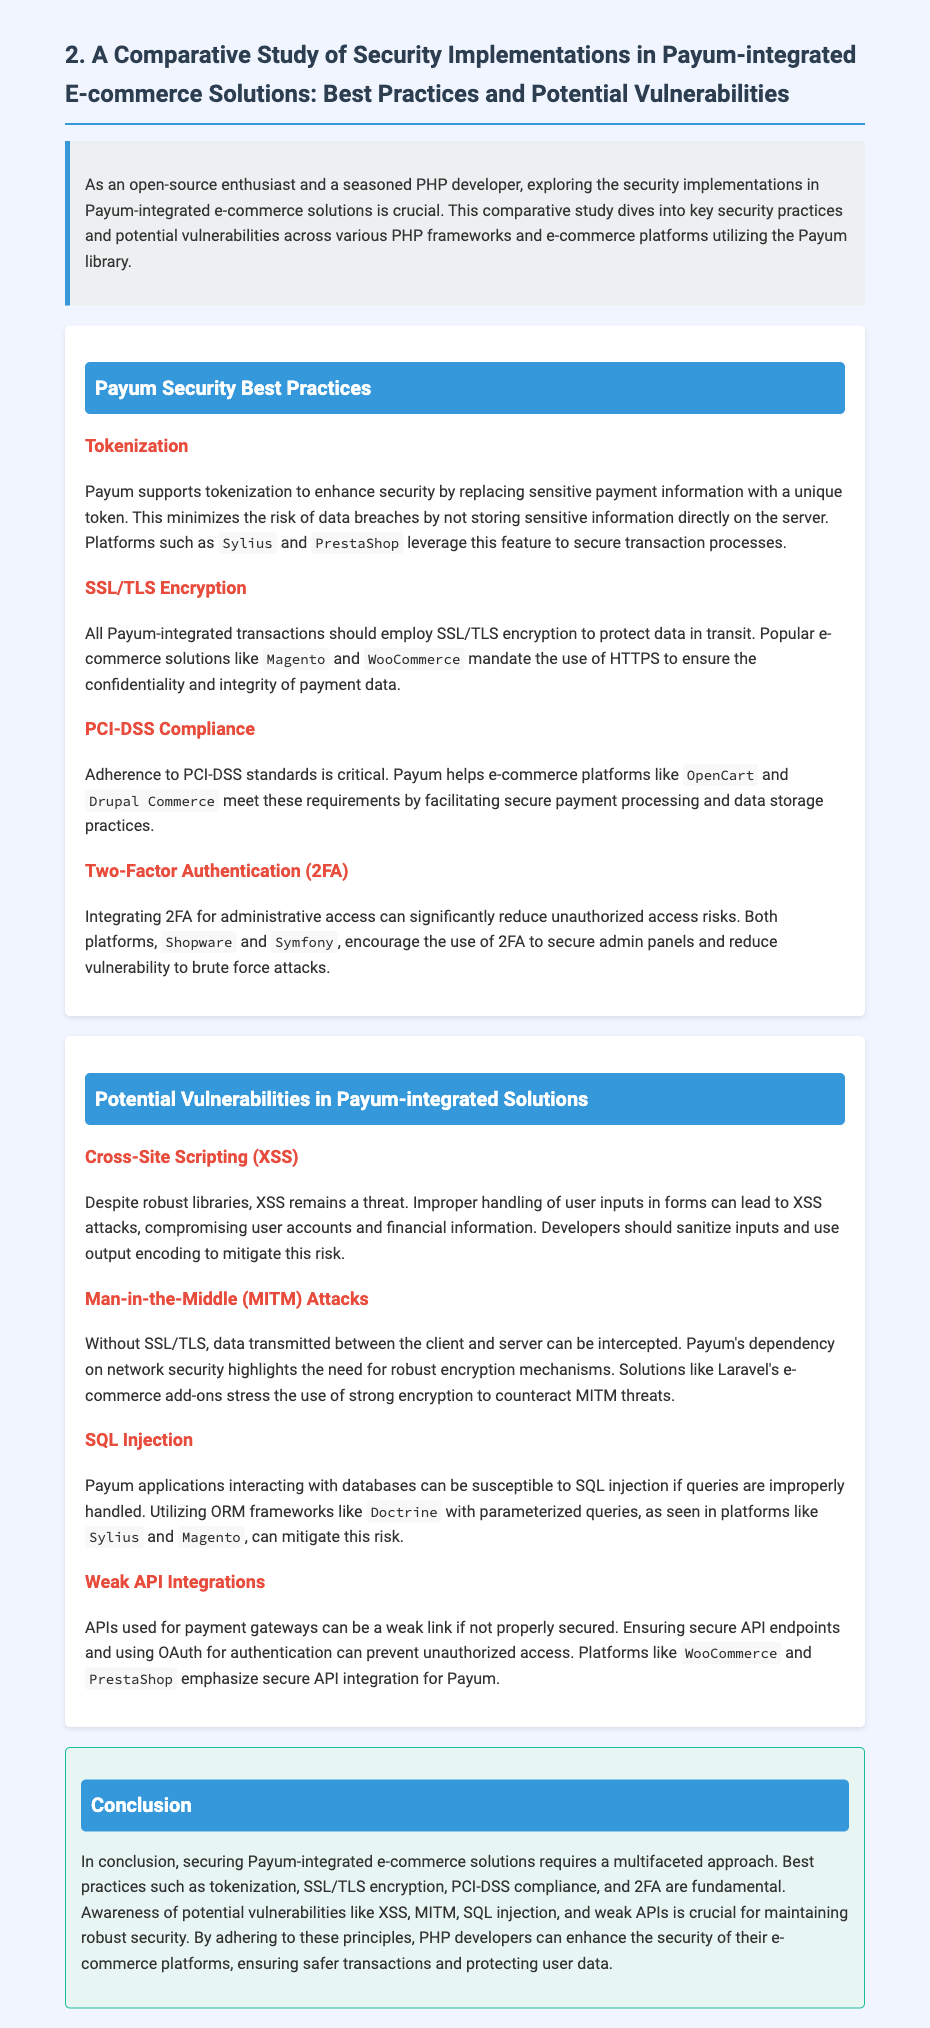What is the title of the document? The title is stated at the top of the document, clearly outlining the subject of the study.
Answer: A Comparative Study of Security Implementations in Payum-integrated E-commerce Solutions: Best Practices and Potential Vulnerabilities Which two platforms leverage tokenization? The document mentions two specific platforms that utilize tokenization for enhanced security.
Answer: Sylius and PrestaShop What encryption method is recommended for Payum-integrated transactions? The document specifies the type of encryption necessary to protect data during payment transactions.
Answer: SSL/TLS How many potential vulnerabilities are identified in Payum-integrated solutions? The document lists the number of vulnerabilities discussed in the section on potential vulnerabilities.
Answer: Four What is a recommended practice for securing administrative access? The document highlights a specific security practice aimed at enhancing admin panel security against unauthorized access.
Answer: Two-Factor Authentication (2FA) What common attack can result from improper input handling? The document addresses a specific type of attack that can occur due to insufficient input sanitization.
Answer: Cross-Site Scripting (XSS) Which ORM framework is mentioned to help prevent SQL injection? The document refers to a specific ORM framework utilized to mitigate SQL injection risks in Payum applications.
Answer: Doctrine What should be evaluated to ensure secure API integrations? The document advises on the process necessary to secure API integrations within e-commerce solutions.
Answer: Secure API endpoints and OAuth for authentication What is emphasized as crucial for maintaining robust security? The conclusion section underscores the importance of being aware of specific risks to maintain security effectively.
Answer: Awareness of potential vulnerabilities 